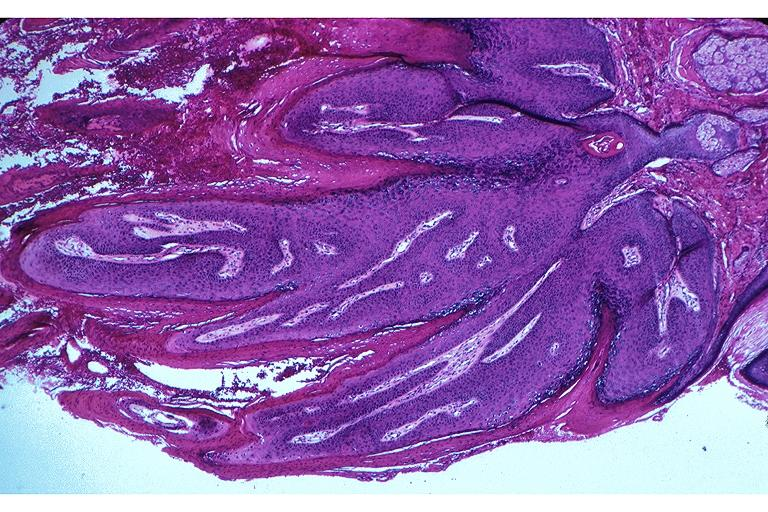does chronic ischemia show papilloma?
Answer the question using a single word or phrase. No 